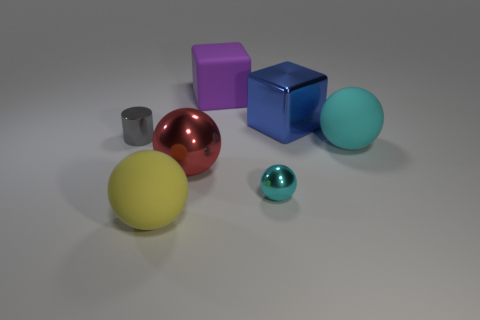Subtract all cyan rubber spheres. How many spheres are left? 3 Subtract all blue blocks. How many blocks are left? 1 Add 3 red things. How many objects exist? 10 Subtract all balls. How many objects are left? 3 Subtract 1 cubes. How many cubes are left? 1 Subtract all blue cylinders. How many purple cubes are left? 1 Subtract all big cyan balls. Subtract all big purple rubber cubes. How many objects are left? 5 Add 6 cyan spheres. How many cyan spheres are left? 8 Add 4 gray things. How many gray things exist? 5 Subtract 0 gray spheres. How many objects are left? 7 